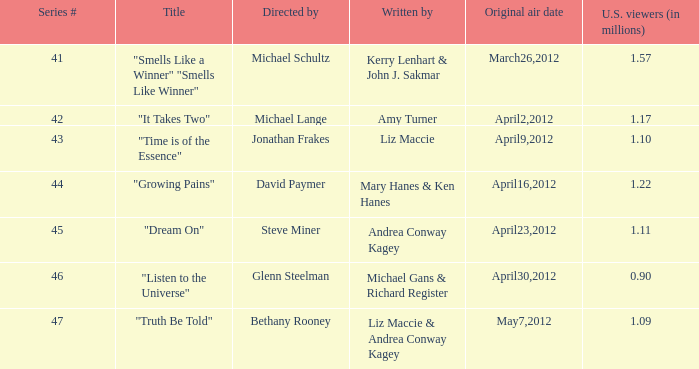How many millions of viewers did the episode written by Andrea Conway Kagey? 1.11. 